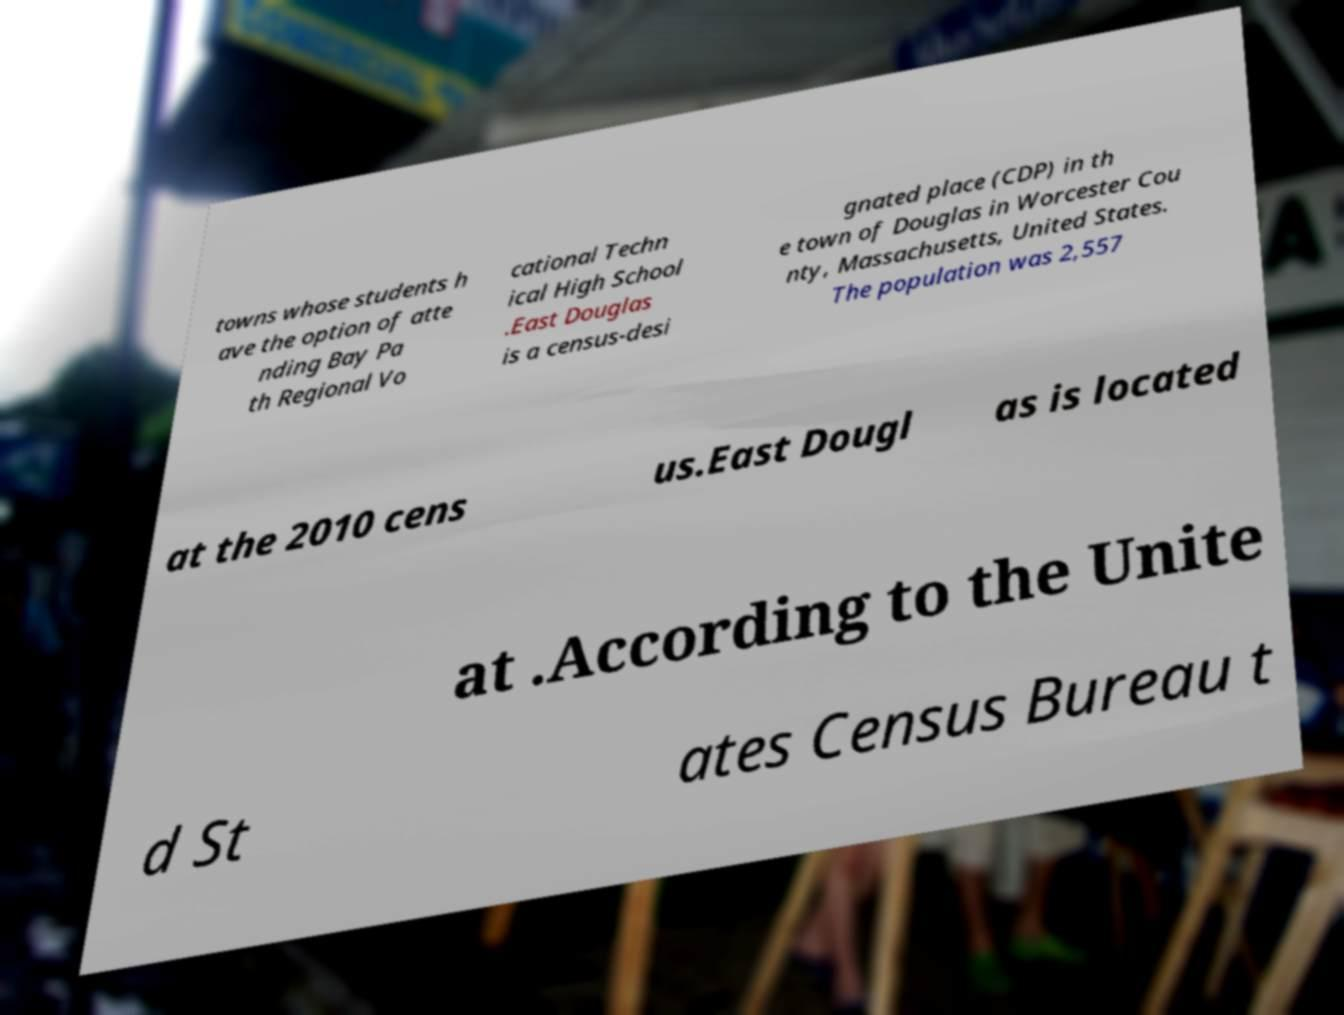I need the written content from this picture converted into text. Can you do that? towns whose students h ave the option of atte nding Bay Pa th Regional Vo cational Techn ical High School .East Douglas is a census-desi gnated place (CDP) in th e town of Douglas in Worcester Cou nty, Massachusetts, United States. The population was 2,557 at the 2010 cens us.East Dougl as is located at .According to the Unite d St ates Census Bureau t 